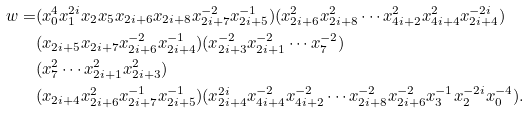Convert formula to latex. <formula><loc_0><loc_0><loc_500><loc_500>w = & ( x _ { 0 } ^ { 4 } x _ { 1 } ^ { 2 i } x _ { 2 } x _ { 5 } x _ { 2 i + 6 } x _ { 2 i + 8 } x _ { 2 i + 7 } ^ { - 2 } x _ { 2 i + 5 } ^ { - 1 } ) ( x _ { 2 i + 6 } ^ { 2 } x _ { 2 i + 8 } ^ { 2 } \cdots x _ { 4 i + 2 } ^ { 2 } x _ { 4 i + 4 } ^ { 2 } x _ { 2 i + 4 } ^ { - 2 i } ) \\ & ( x _ { 2 i + 5 } x _ { 2 i + 7 } x _ { 2 i + 6 } ^ { - 2 } x _ { 2 i + 4 } ^ { - 1 } ) ( x _ { 2 i + 3 } ^ { - 2 } x _ { 2 i + 1 } ^ { - 2 } \cdots x _ { 7 } ^ { - 2 } ) \\ & ( x _ { 7 } ^ { 2 } \cdots x _ { 2 i + 1 } ^ { 2 } x _ { 2 i + 3 } ^ { 2 } ) \\ & ( x _ { 2 i + 4 } x _ { 2 i + 6 } ^ { 2 } x _ { 2 i + 7 } ^ { - 1 } x _ { 2 i + 5 } ^ { - 1 } ) ( x _ { 2 i + 4 } ^ { 2 i } x _ { 4 i + 4 } ^ { - 2 } x _ { 4 i + 2 } ^ { - 2 } \cdots x _ { 2 i + 8 } ^ { - 2 } x _ { 2 i + 6 } ^ { - 2 } x _ { 3 } ^ { - 1 } x _ { 2 } ^ { - 2 i } x _ { 0 } ^ { - 4 } ) .</formula> 